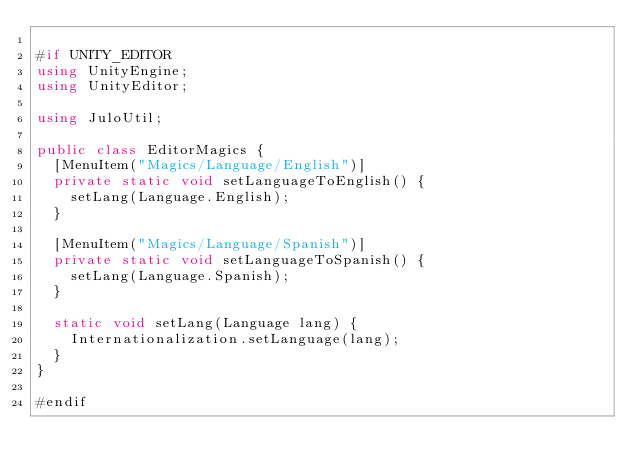<code> <loc_0><loc_0><loc_500><loc_500><_C#_>
#if UNITY_EDITOR
using UnityEngine;
using UnityEditor;

using JuloUtil;

public class EditorMagics {
	[MenuItem("Magics/Language/English")]
	private static void setLanguageToEnglish() {
		setLang(Language.English);
	}
	
	[MenuItem("Magics/Language/Spanish")]
	private static void setLanguageToSpanish() {
		setLang(Language.Spanish);
	}
	
	static void setLang(Language lang) {
		Internationalization.setLanguage(lang);
	}
}

#endif
</code> 